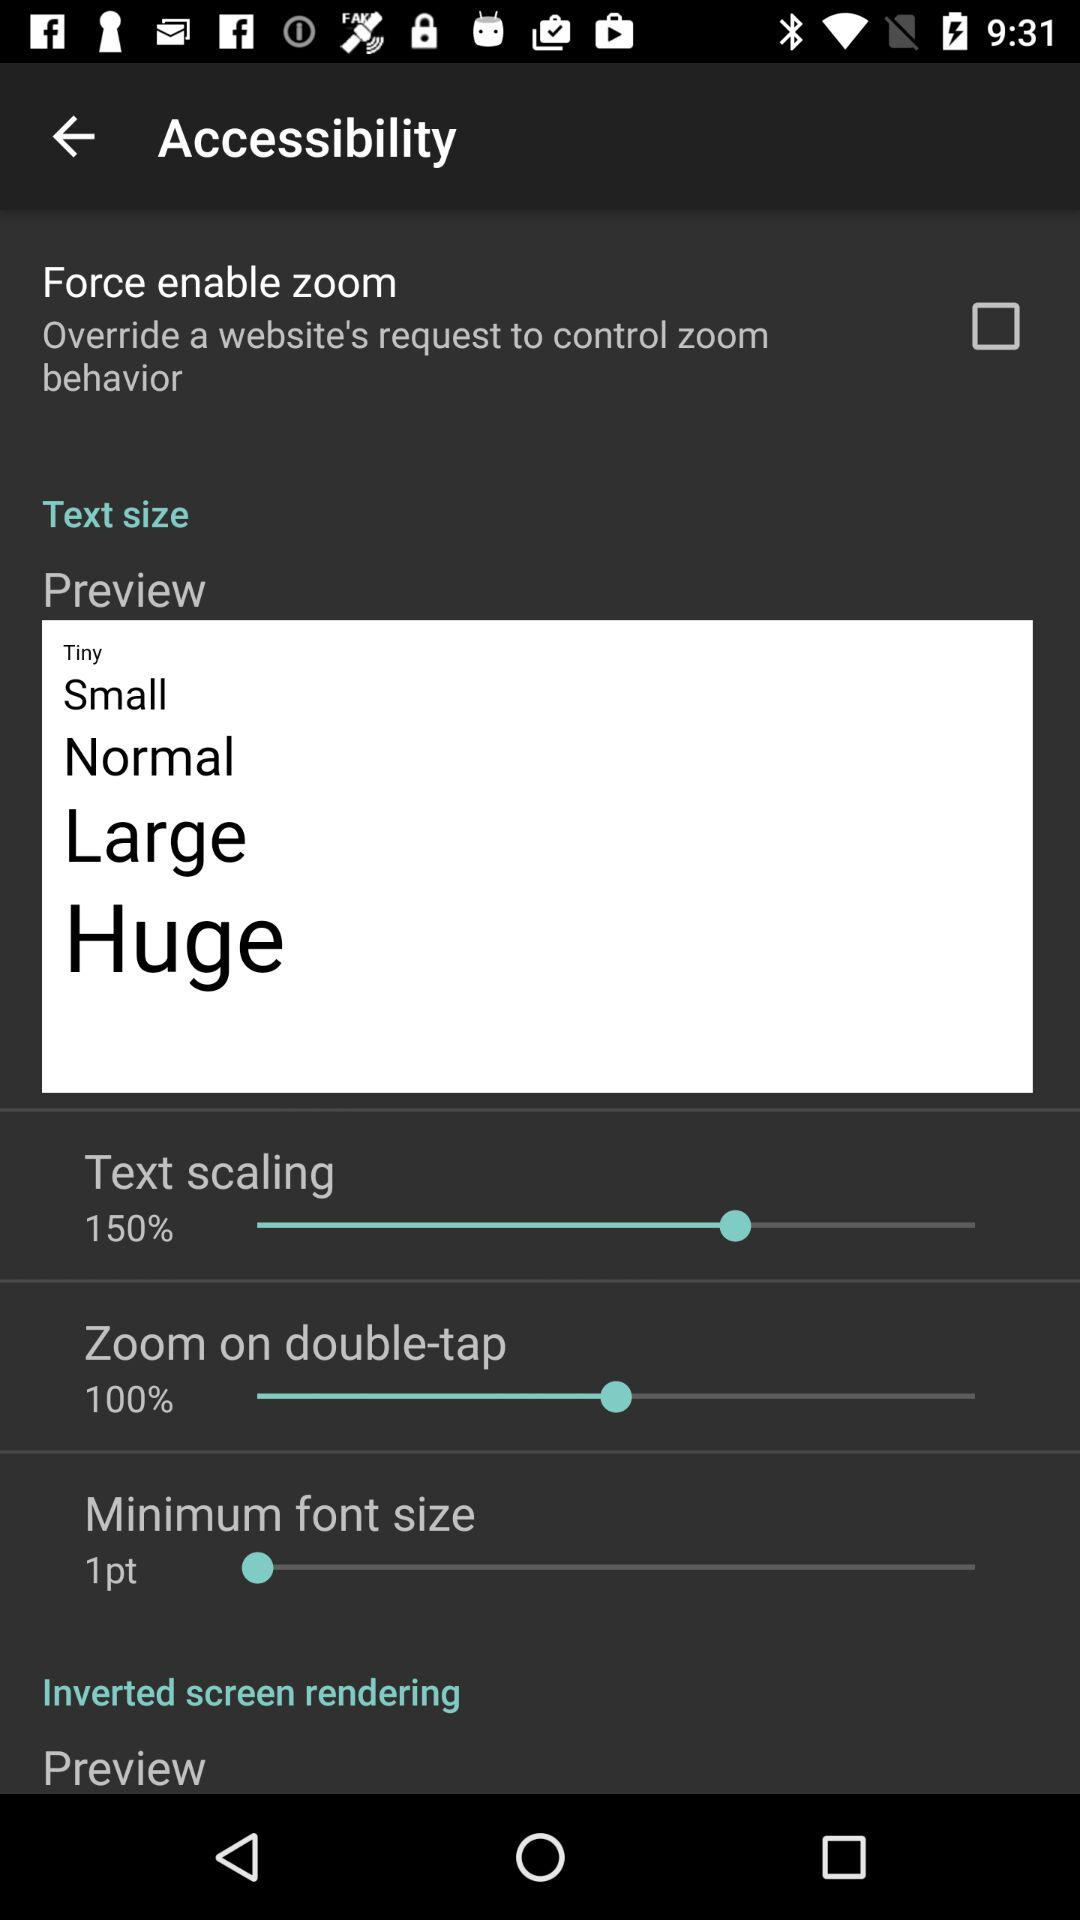What is the selected text scaling percentage? The selected text scaling percentage is 150. 